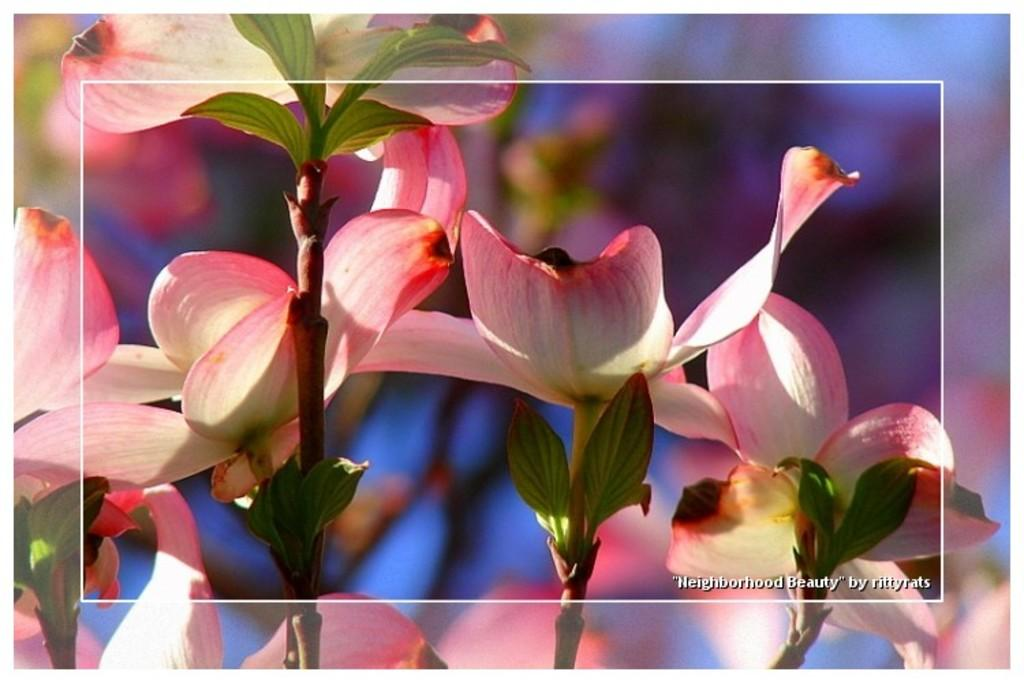What type of living organisms can be seen in the image? There are flowers in the image. Where are the flowers located? The flowers are on plants. What type of sail can be seen on the flowers in the image? There is no sail present on the flowers in the image. 